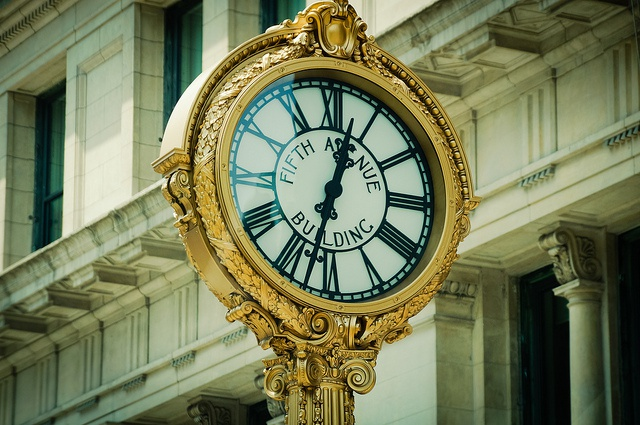Describe the objects in this image and their specific colors. I can see a clock in black, lightgray, darkgray, and tan tones in this image. 